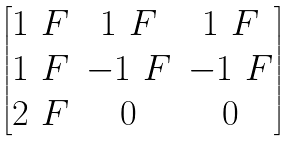Convert formula to latex. <formula><loc_0><loc_0><loc_500><loc_500>\begin{bmatrix} 1 _ { \ } F & 1 _ { \ } F & 1 _ { \ } F \\ 1 _ { \ } F & - 1 _ { \ } F & - 1 _ { \ } F \\ 2 _ { \ } F & 0 & 0 \end{bmatrix}</formula> 